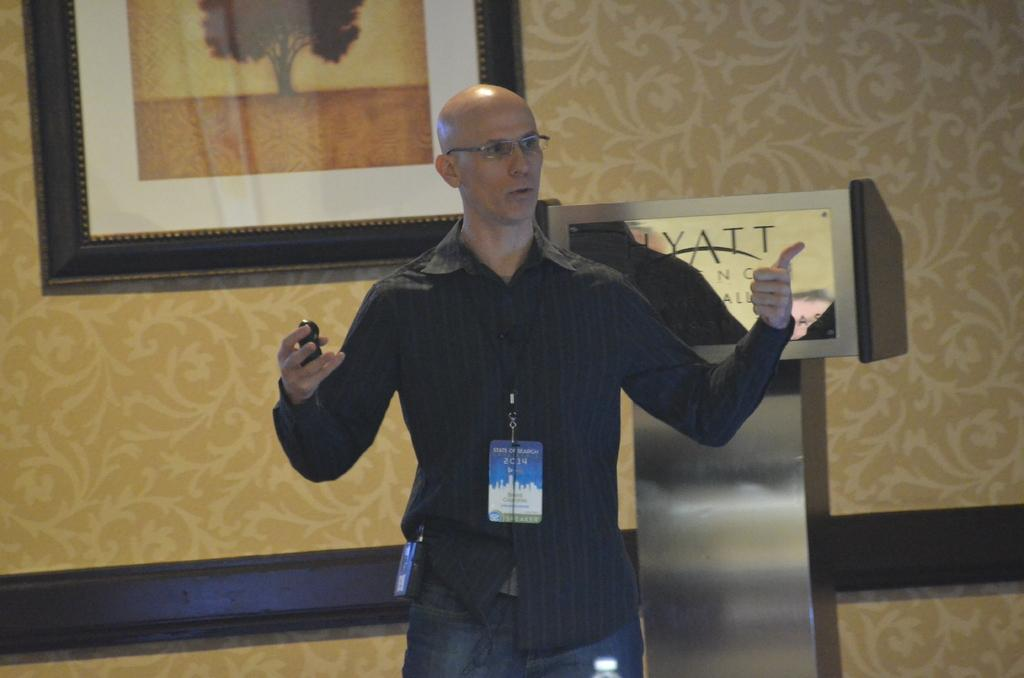What is the person in the image holding? The person is holding an object in the image. What can be seen near the person in the image? There is a podium with a board in the image. What is written or displayed on the board? There is text on the board. What type of wall is visible in the image? There is a design wall in the image. What is attached to the design wall? There is a photo frame on the design wall. What type of animal can be seen sleeping on the sheet in the image? There is no animal or sheet present in the image. 